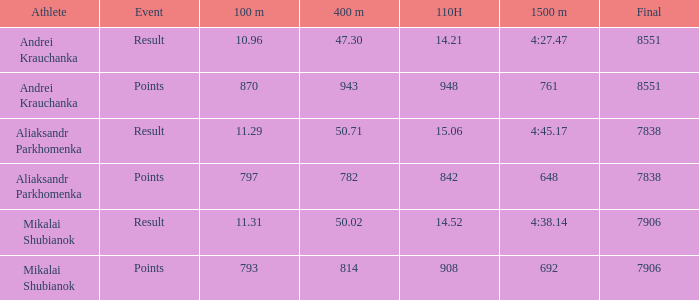3? None. 